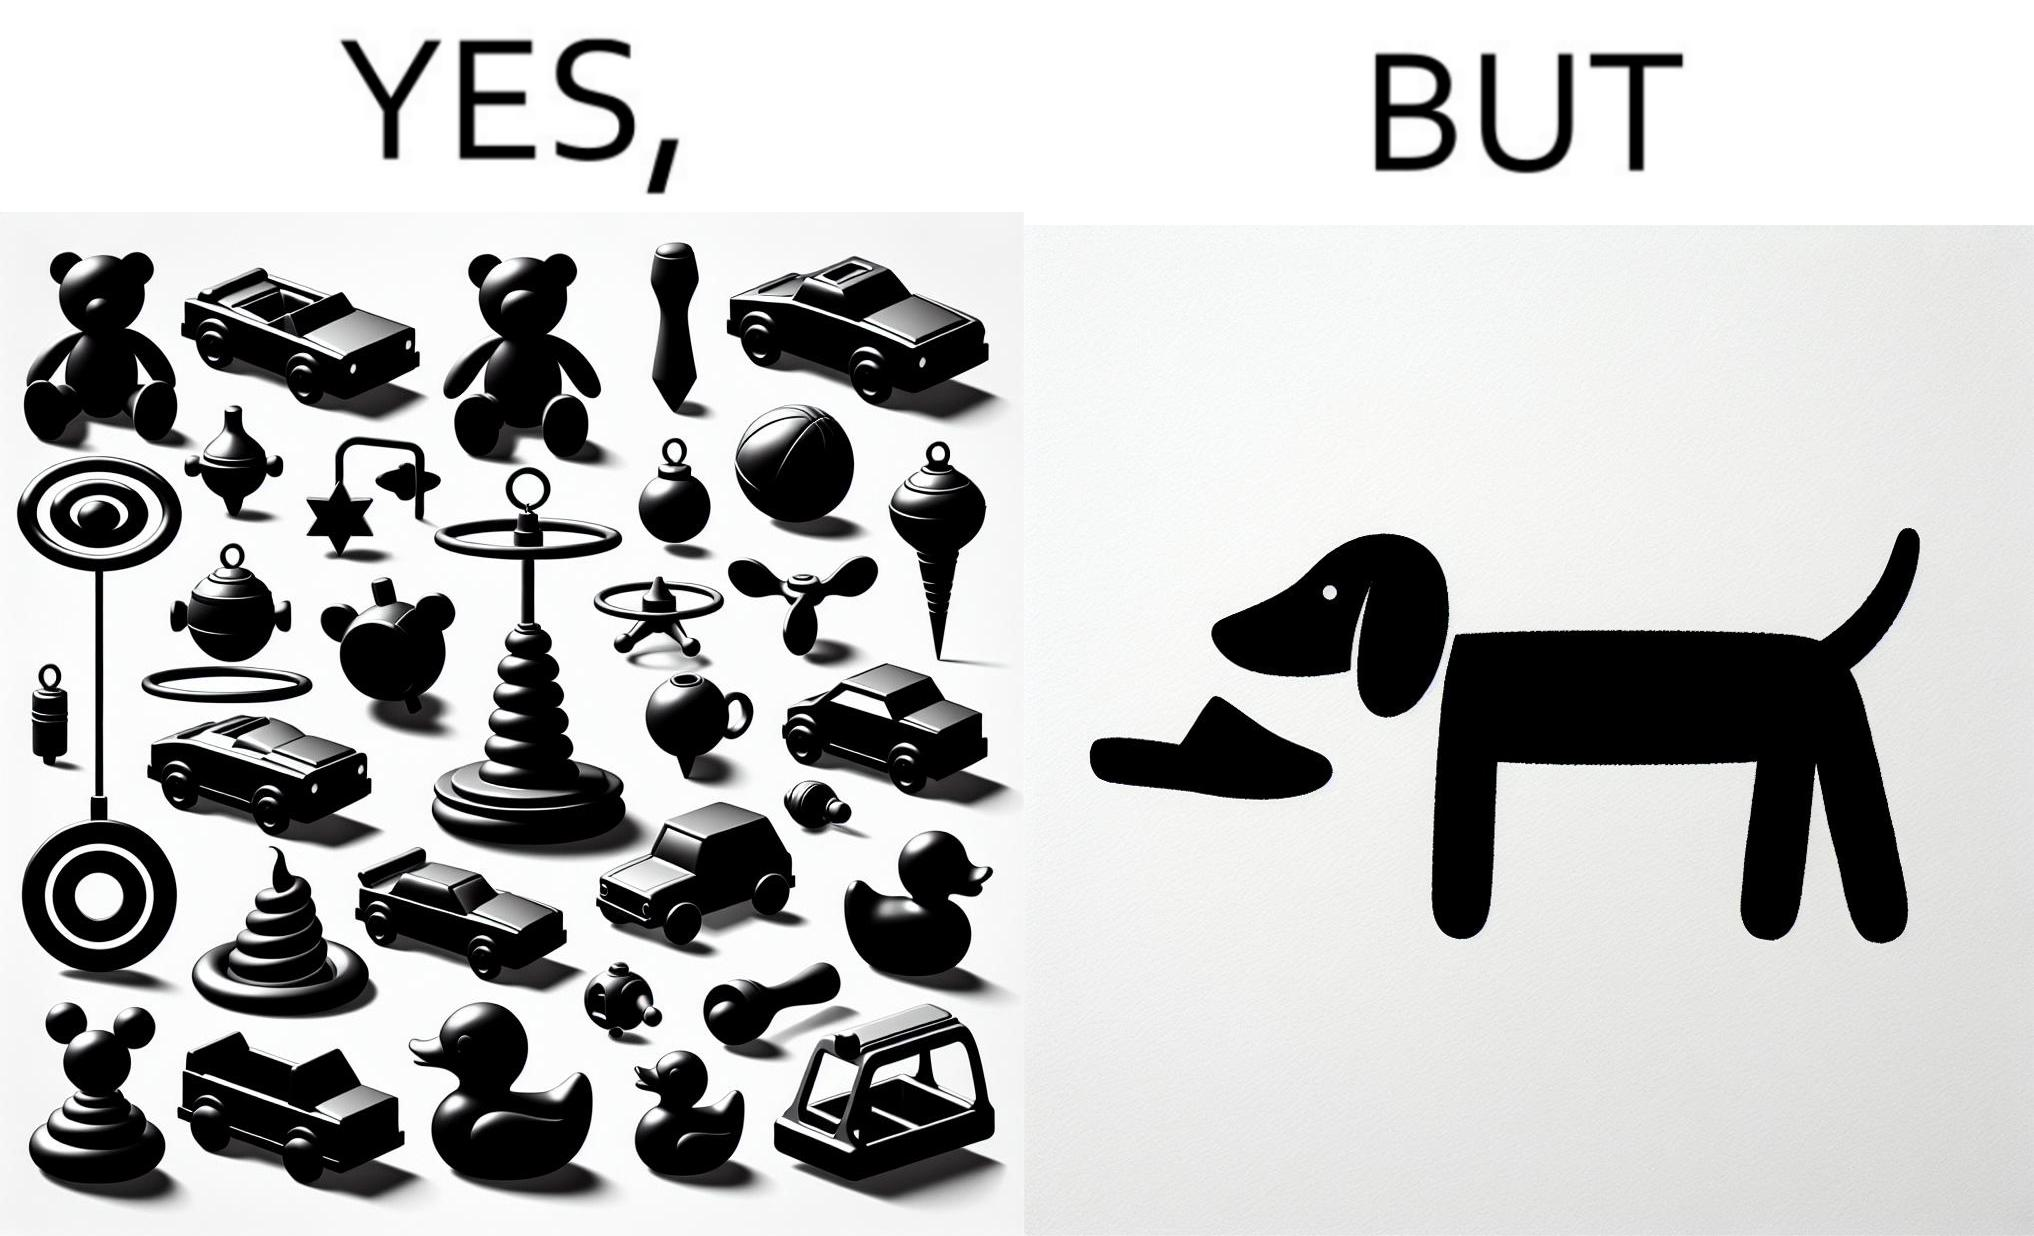What does this image depict? the irony is that dog owners buy loads of toys for their dog but the dog's favourite toy is the owner's slippers 